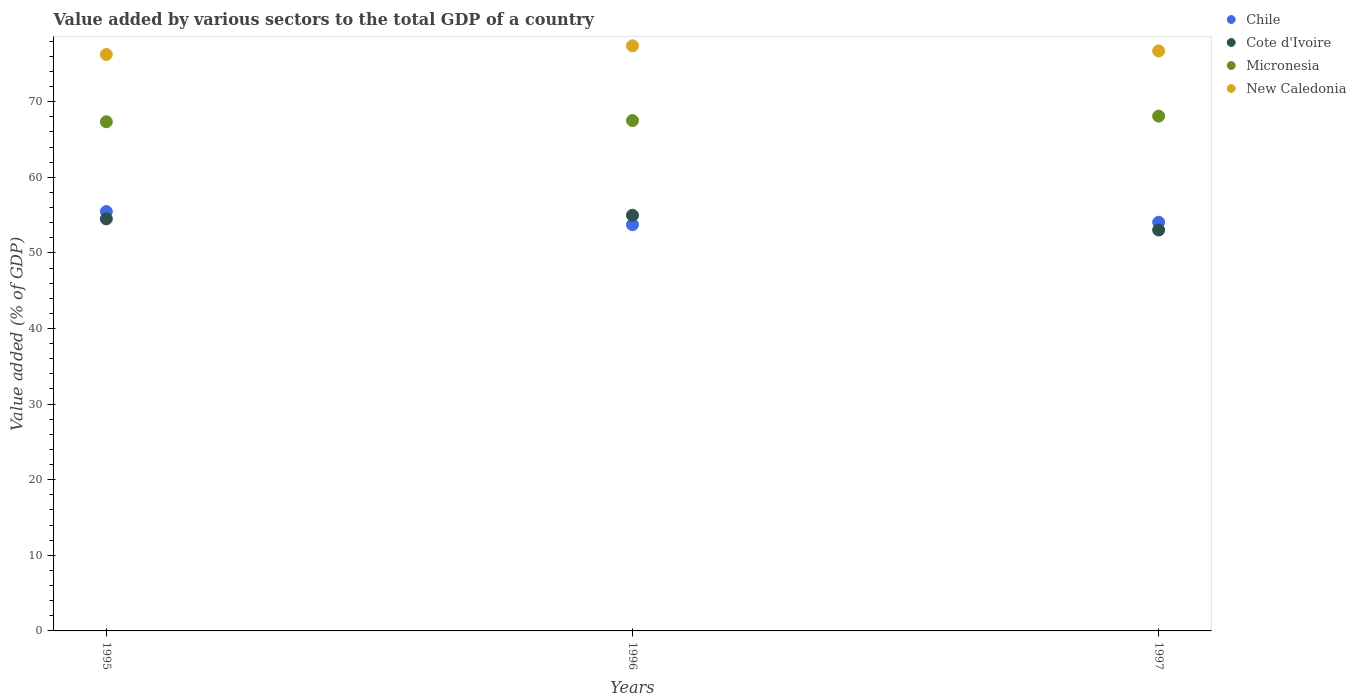Is the number of dotlines equal to the number of legend labels?
Offer a terse response. Yes. What is the value added by various sectors to the total GDP in Micronesia in 1995?
Offer a terse response. 67.35. Across all years, what is the maximum value added by various sectors to the total GDP in Cote d'Ivoire?
Ensure brevity in your answer.  54.98. Across all years, what is the minimum value added by various sectors to the total GDP in Cote d'Ivoire?
Your answer should be compact. 53.03. What is the total value added by various sectors to the total GDP in Chile in the graph?
Provide a succinct answer. 163.26. What is the difference between the value added by various sectors to the total GDP in Cote d'Ivoire in 1996 and that in 1997?
Your answer should be compact. 1.95. What is the difference between the value added by various sectors to the total GDP in Micronesia in 1997 and the value added by various sectors to the total GDP in New Caledonia in 1996?
Your answer should be compact. -9.3. What is the average value added by various sectors to the total GDP in New Caledonia per year?
Your answer should be compact. 76.79. In the year 1996, what is the difference between the value added by various sectors to the total GDP in Micronesia and value added by various sectors to the total GDP in Cote d'Ivoire?
Your answer should be very brief. 12.53. In how many years, is the value added by various sectors to the total GDP in Micronesia greater than 30 %?
Offer a terse response. 3. What is the ratio of the value added by various sectors to the total GDP in Chile in 1995 to that in 1996?
Give a very brief answer. 1.03. What is the difference between the highest and the second highest value added by various sectors to the total GDP in Chile?
Your response must be concise. 1.42. What is the difference between the highest and the lowest value added by various sectors to the total GDP in Micronesia?
Provide a succinct answer. 0.75. Is the sum of the value added by various sectors to the total GDP in Cote d'Ivoire in 1996 and 1997 greater than the maximum value added by various sectors to the total GDP in New Caledonia across all years?
Make the answer very short. Yes. Does the value added by various sectors to the total GDP in New Caledonia monotonically increase over the years?
Offer a very short reply. No. Is the value added by various sectors to the total GDP in Micronesia strictly greater than the value added by various sectors to the total GDP in Chile over the years?
Your response must be concise. Yes. Is the value added by various sectors to the total GDP in Chile strictly less than the value added by various sectors to the total GDP in Cote d'Ivoire over the years?
Give a very brief answer. No. How many dotlines are there?
Give a very brief answer. 4. Are the values on the major ticks of Y-axis written in scientific E-notation?
Provide a succinct answer. No. How are the legend labels stacked?
Offer a terse response. Vertical. What is the title of the graph?
Give a very brief answer. Value added by various sectors to the total GDP of a country. What is the label or title of the Y-axis?
Ensure brevity in your answer.  Value added (% of GDP). What is the Value added (% of GDP) in Chile in 1995?
Ensure brevity in your answer.  55.47. What is the Value added (% of GDP) of Cote d'Ivoire in 1995?
Provide a short and direct response. 54.5. What is the Value added (% of GDP) of Micronesia in 1995?
Provide a succinct answer. 67.35. What is the Value added (% of GDP) of New Caledonia in 1995?
Give a very brief answer. 76.24. What is the Value added (% of GDP) of Chile in 1996?
Ensure brevity in your answer.  53.73. What is the Value added (% of GDP) of Cote d'Ivoire in 1996?
Keep it short and to the point. 54.98. What is the Value added (% of GDP) in Micronesia in 1996?
Make the answer very short. 67.5. What is the Value added (% of GDP) in New Caledonia in 1996?
Provide a succinct answer. 77.4. What is the Value added (% of GDP) in Chile in 1997?
Make the answer very short. 54.05. What is the Value added (% of GDP) of Cote d'Ivoire in 1997?
Your response must be concise. 53.03. What is the Value added (% of GDP) in Micronesia in 1997?
Your response must be concise. 68.09. What is the Value added (% of GDP) in New Caledonia in 1997?
Provide a short and direct response. 76.71. Across all years, what is the maximum Value added (% of GDP) of Chile?
Offer a very short reply. 55.47. Across all years, what is the maximum Value added (% of GDP) in Cote d'Ivoire?
Ensure brevity in your answer.  54.98. Across all years, what is the maximum Value added (% of GDP) of Micronesia?
Give a very brief answer. 68.09. Across all years, what is the maximum Value added (% of GDP) of New Caledonia?
Give a very brief answer. 77.4. Across all years, what is the minimum Value added (% of GDP) in Chile?
Ensure brevity in your answer.  53.73. Across all years, what is the minimum Value added (% of GDP) of Cote d'Ivoire?
Keep it short and to the point. 53.03. Across all years, what is the minimum Value added (% of GDP) in Micronesia?
Offer a terse response. 67.35. Across all years, what is the minimum Value added (% of GDP) in New Caledonia?
Give a very brief answer. 76.24. What is the total Value added (% of GDP) in Chile in the graph?
Give a very brief answer. 163.26. What is the total Value added (% of GDP) of Cote d'Ivoire in the graph?
Your answer should be very brief. 162.51. What is the total Value added (% of GDP) in Micronesia in the graph?
Provide a short and direct response. 202.95. What is the total Value added (% of GDP) in New Caledonia in the graph?
Offer a terse response. 230.36. What is the difference between the Value added (% of GDP) in Chile in 1995 and that in 1996?
Your answer should be very brief. 1.74. What is the difference between the Value added (% of GDP) of Cote d'Ivoire in 1995 and that in 1996?
Offer a terse response. -0.47. What is the difference between the Value added (% of GDP) in Micronesia in 1995 and that in 1996?
Ensure brevity in your answer.  -0.16. What is the difference between the Value added (% of GDP) in New Caledonia in 1995 and that in 1996?
Your response must be concise. -1.15. What is the difference between the Value added (% of GDP) of Chile in 1995 and that in 1997?
Provide a short and direct response. 1.42. What is the difference between the Value added (% of GDP) of Cote d'Ivoire in 1995 and that in 1997?
Offer a terse response. 1.47. What is the difference between the Value added (% of GDP) in Micronesia in 1995 and that in 1997?
Your response must be concise. -0.75. What is the difference between the Value added (% of GDP) in New Caledonia in 1995 and that in 1997?
Offer a terse response. -0.47. What is the difference between the Value added (% of GDP) of Chile in 1996 and that in 1997?
Offer a very short reply. -0.32. What is the difference between the Value added (% of GDP) of Cote d'Ivoire in 1996 and that in 1997?
Keep it short and to the point. 1.95. What is the difference between the Value added (% of GDP) in Micronesia in 1996 and that in 1997?
Your answer should be compact. -0.59. What is the difference between the Value added (% of GDP) of New Caledonia in 1996 and that in 1997?
Provide a short and direct response. 0.68. What is the difference between the Value added (% of GDP) in Chile in 1995 and the Value added (% of GDP) in Cote d'Ivoire in 1996?
Make the answer very short. 0.49. What is the difference between the Value added (% of GDP) in Chile in 1995 and the Value added (% of GDP) in Micronesia in 1996?
Provide a short and direct response. -12.03. What is the difference between the Value added (% of GDP) of Chile in 1995 and the Value added (% of GDP) of New Caledonia in 1996?
Offer a terse response. -21.93. What is the difference between the Value added (% of GDP) in Cote d'Ivoire in 1995 and the Value added (% of GDP) in Micronesia in 1996?
Make the answer very short. -13. What is the difference between the Value added (% of GDP) of Cote d'Ivoire in 1995 and the Value added (% of GDP) of New Caledonia in 1996?
Make the answer very short. -22.89. What is the difference between the Value added (% of GDP) in Micronesia in 1995 and the Value added (% of GDP) in New Caledonia in 1996?
Provide a short and direct response. -10.05. What is the difference between the Value added (% of GDP) in Chile in 1995 and the Value added (% of GDP) in Cote d'Ivoire in 1997?
Provide a succinct answer. 2.44. What is the difference between the Value added (% of GDP) of Chile in 1995 and the Value added (% of GDP) of Micronesia in 1997?
Offer a terse response. -12.62. What is the difference between the Value added (% of GDP) in Chile in 1995 and the Value added (% of GDP) in New Caledonia in 1997?
Offer a terse response. -21.24. What is the difference between the Value added (% of GDP) of Cote d'Ivoire in 1995 and the Value added (% of GDP) of Micronesia in 1997?
Give a very brief answer. -13.59. What is the difference between the Value added (% of GDP) of Cote d'Ivoire in 1995 and the Value added (% of GDP) of New Caledonia in 1997?
Your answer should be compact. -22.21. What is the difference between the Value added (% of GDP) in Micronesia in 1995 and the Value added (% of GDP) in New Caledonia in 1997?
Keep it short and to the point. -9.37. What is the difference between the Value added (% of GDP) of Chile in 1996 and the Value added (% of GDP) of Cote d'Ivoire in 1997?
Give a very brief answer. 0.7. What is the difference between the Value added (% of GDP) in Chile in 1996 and the Value added (% of GDP) in Micronesia in 1997?
Your answer should be very brief. -14.36. What is the difference between the Value added (% of GDP) of Chile in 1996 and the Value added (% of GDP) of New Caledonia in 1997?
Provide a short and direct response. -22.98. What is the difference between the Value added (% of GDP) of Cote d'Ivoire in 1996 and the Value added (% of GDP) of Micronesia in 1997?
Make the answer very short. -13.12. What is the difference between the Value added (% of GDP) of Cote d'Ivoire in 1996 and the Value added (% of GDP) of New Caledonia in 1997?
Make the answer very short. -21.73. What is the difference between the Value added (% of GDP) of Micronesia in 1996 and the Value added (% of GDP) of New Caledonia in 1997?
Provide a short and direct response. -9.21. What is the average Value added (% of GDP) of Chile per year?
Provide a succinct answer. 54.42. What is the average Value added (% of GDP) in Cote d'Ivoire per year?
Offer a terse response. 54.17. What is the average Value added (% of GDP) of Micronesia per year?
Keep it short and to the point. 67.65. What is the average Value added (% of GDP) in New Caledonia per year?
Keep it short and to the point. 76.78. In the year 1995, what is the difference between the Value added (% of GDP) of Chile and Value added (% of GDP) of Cote d'Ivoire?
Provide a succinct answer. 0.97. In the year 1995, what is the difference between the Value added (% of GDP) of Chile and Value added (% of GDP) of Micronesia?
Your response must be concise. -11.88. In the year 1995, what is the difference between the Value added (% of GDP) in Chile and Value added (% of GDP) in New Caledonia?
Offer a very short reply. -20.77. In the year 1995, what is the difference between the Value added (% of GDP) in Cote d'Ivoire and Value added (% of GDP) in Micronesia?
Offer a terse response. -12.84. In the year 1995, what is the difference between the Value added (% of GDP) in Cote d'Ivoire and Value added (% of GDP) in New Caledonia?
Keep it short and to the point. -21.74. In the year 1995, what is the difference between the Value added (% of GDP) of Micronesia and Value added (% of GDP) of New Caledonia?
Offer a very short reply. -8.89. In the year 1996, what is the difference between the Value added (% of GDP) of Chile and Value added (% of GDP) of Cote d'Ivoire?
Ensure brevity in your answer.  -1.24. In the year 1996, what is the difference between the Value added (% of GDP) of Chile and Value added (% of GDP) of Micronesia?
Your answer should be compact. -13.77. In the year 1996, what is the difference between the Value added (% of GDP) of Chile and Value added (% of GDP) of New Caledonia?
Make the answer very short. -23.66. In the year 1996, what is the difference between the Value added (% of GDP) in Cote d'Ivoire and Value added (% of GDP) in Micronesia?
Give a very brief answer. -12.53. In the year 1996, what is the difference between the Value added (% of GDP) of Cote d'Ivoire and Value added (% of GDP) of New Caledonia?
Give a very brief answer. -22.42. In the year 1996, what is the difference between the Value added (% of GDP) in Micronesia and Value added (% of GDP) in New Caledonia?
Make the answer very short. -9.89. In the year 1997, what is the difference between the Value added (% of GDP) of Chile and Value added (% of GDP) of Cote d'Ivoire?
Offer a very short reply. 1.02. In the year 1997, what is the difference between the Value added (% of GDP) of Chile and Value added (% of GDP) of Micronesia?
Provide a short and direct response. -14.04. In the year 1997, what is the difference between the Value added (% of GDP) of Chile and Value added (% of GDP) of New Caledonia?
Make the answer very short. -22.66. In the year 1997, what is the difference between the Value added (% of GDP) of Cote d'Ivoire and Value added (% of GDP) of Micronesia?
Ensure brevity in your answer.  -15.06. In the year 1997, what is the difference between the Value added (% of GDP) in Cote d'Ivoire and Value added (% of GDP) in New Caledonia?
Provide a succinct answer. -23.68. In the year 1997, what is the difference between the Value added (% of GDP) in Micronesia and Value added (% of GDP) in New Caledonia?
Offer a very short reply. -8.62. What is the ratio of the Value added (% of GDP) in Chile in 1995 to that in 1996?
Ensure brevity in your answer.  1.03. What is the ratio of the Value added (% of GDP) of Cote d'Ivoire in 1995 to that in 1996?
Offer a very short reply. 0.99. What is the ratio of the Value added (% of GDP) in Micronesia in 1995 to that in 1996?
Give a very brief answer. 1. What is the ratio of the Value added (% of GDP) of New Caledonia in 1995 to that in 1996?
Make the answer very short. 0.99. What is the ratio of the Value added (% of GDP) in Chile in 1995 to that in 1997?
Your response must be concise. 1.03. What is the ratio of the Value added (% of GDP) in Cote d'Ivoire in 1995 to that in 1997?
Give a very brief answer. 1.03. What is the ratio of the Value added (% of GDP) in New Caledonia in 1995 to that in 1997?
Your answer should be very brief. 0.99. What is the ratio of the Value added (% of GDP) of Cote d'Ivoire in 1996 to that in 1997?
Offer a very short reply. 1.04. What is the ratio of the Value added (% of GDP) of New Caledonia in 1996 to that in 1997?
Provide a succinct answer. 1.01. What is the difference between the highest and the second highest Value added (% of GDP) of Chile?
Offer a very short reply. 1.42. What is the difference between the highest and the second highest Value added (% of GDP) of Cote d'Ivoire?
Provide a short and direct response. 0.47. What is the difference between the highest and the second highest Value added (% of GDP) of Micronesia?
Keep it short and to the point. 0.59. What is the difference between the highest and the second highest Value added (% of GDP) of New Caledonia?
Your answer should be compact. 0.68. What is the difference between the highest and the lowest Value added (% of GDP) in Chile?
Offer a terse response. 1.74. What is the difference between the highest and the lowest Value added (% of GDP) of Cote d'Ivoire?
Offer a very short reply. 1.95. What is the difference between the highest and the lowest Value added (% of GDP) of Micronesia?
Ensure brevity in your answer.  0.75. What is the difference between the highest and the lowest Value added (% of GDP) of New Caledonia?
Provide a short and direct response. 1.15. 